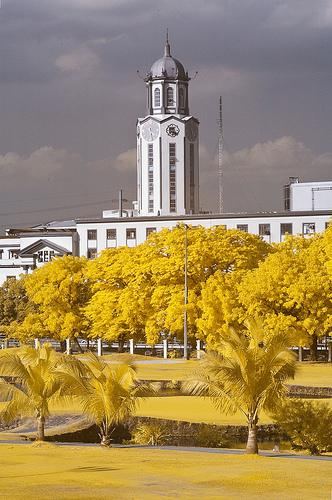Count the number of trees visible in the image, including those in the background. There are 7 trees in total: 6 very beautiful trees and 1 tree in the background. In the image, how many windows can be seen on one of the buildings? There are five windows visible on the building. List three objects related to the ground in the image and their characteristics. 3. Short yellow palm trees on the ground. Identify any power-related infrastructure present in the image. There are black power lines in the air over the buildings. What type of landscape is depicted in the image? A beautiful landscape with trees, buildings, and a cloudy sky is depicted in the image. Describe the appearance of the building in the background. The building in the background is white, with many windows, a round light grey clock on the side, and a steeple at the top. Mention the type of fence present in the image and its appearance. There is a metal fence in the image with white fence poles, and the edge of the fence is visible. Describe any visible tree trunks in the image and their color. Two visible tree trunks in the image are brown, with one of them being a part of a very beautiful tree. Point out any noticeable object or structure on the top of the buildings. There are two noticeable structures on the top of the building: a steeple and a tower with three clocks. Identify the predominant color of the sky in the image. The sky in the image is predominantly blue with white clouds scattered around. The golden statue on top of the steeple adds a regal touch to the display. No, it's not mentioned in the image. 